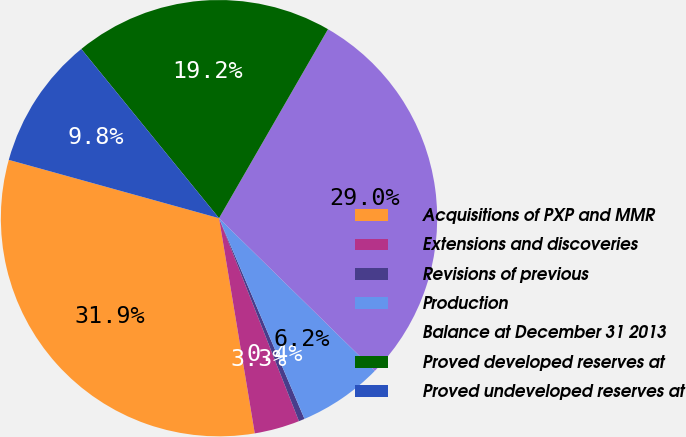Convert chart. <chart><loc_0><loc_0><loc_500><loc_500><pie_chart><fcel>Acquisitions of PXP and MMR<fcel>Extensions and discoveries<fcel>Revisions of previous<fcel>Production<fcel>Balance at December 31 2013<fcel>Proved developed reserves at<fcel>Proved undeveloped reserves at<nl><fcel>31.93%<fcel>3.35%<fcel>0.44%<fcel>6.25%<fcel>29.02%<fcel>19.2%<fcel>9.82%<nl></chart> 